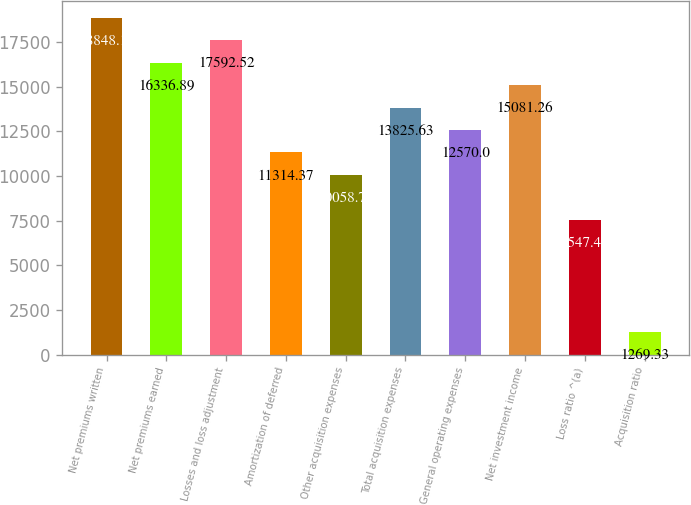Convert chart. <chart><loc_0><loc_0><loc_500><loc_500><bar_chart><fcel>Net premiums written<fcel>Net premiums earned<fcel>Losses and loss adjustment<fcel>Amortization of deferred<fcel>Other acquisition expenses<fcel>Total acquisition expenses<fcel>General operating expenses<fcel>Net investment income<fcel>Loss ratio ^(a)<fcel>Acquisition ratio<nl><fcel>18848.2<fcel>16336.9<fcel>17592.5<fcel>11314.4<fcel>10058.7<fcel>13825.6<fcel>12570<fcel>15081.3<fcel>7547.48<fcel>1269.33<nl></chart> 